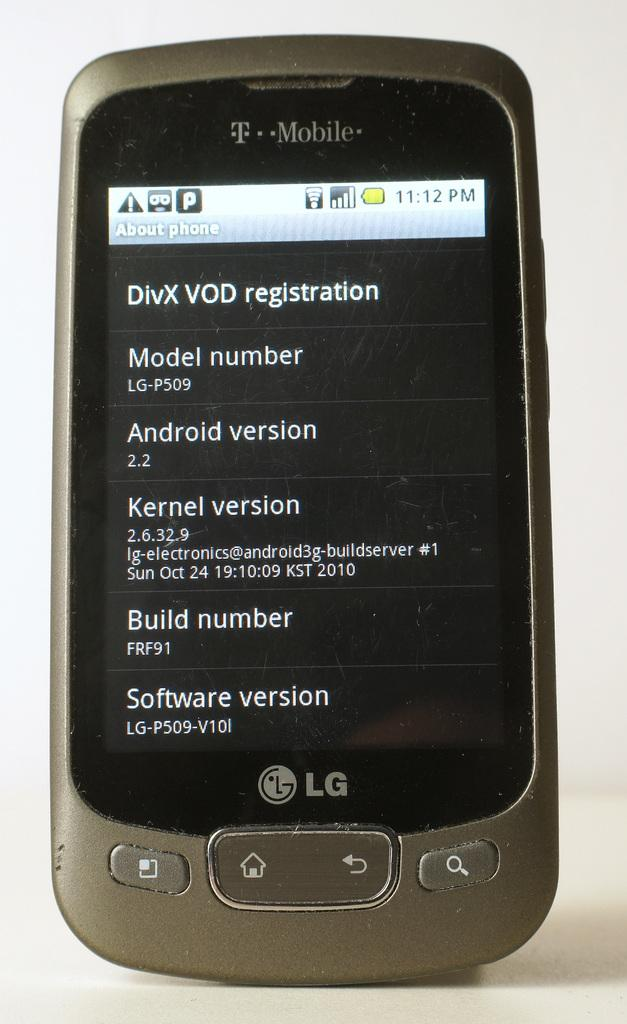<image>
Summarize the visual content of the image. The screen of an LG branded cell phone that is looking at its software settings. 